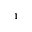Convert formula to latex. <formula><loc_0><loc_0><loc_500><loc_500>^ { 1 }</formula> 